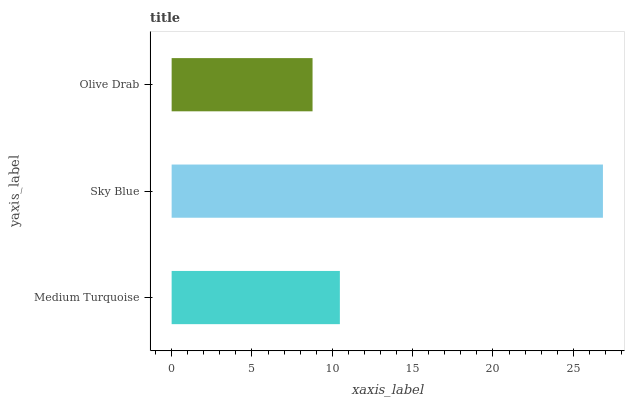Is Olive Drab the minimum?
Answer yes or no. Yes. Is Sky Blue the maximum?
Answer yes or no. Yes. Is Sky Blue the minimum?
Answer yes or no. No. Is Olive Drab the maximum?
Answer yes or no. No. Is Sky Blue greater than Olive Drab?
Answer yes or no. Yes. Is Olive Drab less than Sky Blue?
Answer yes or no. Yes. Is Olive Drab greater than Sky Blue?
Answer yes or no. No. Is Sky Blue less than Olive Drab?
Answer yes or no. No. Is Medium Turquoise the high median?
Answer yes or no. Yes. Is Medium Turquoise the low median?
Answer yes or no. Yes. Is Sky Blue the high median?
Answer yes or no. No. Is Olive Drab the low median?
Answer yes or no. No. 